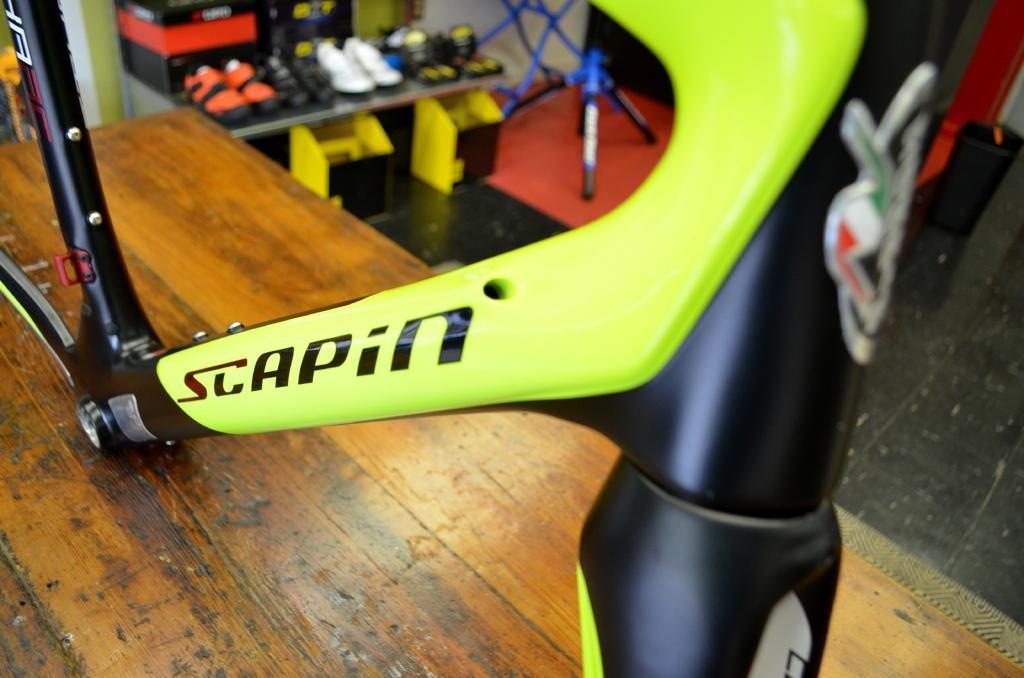What is the main object on the wooden surface in the image? There is a bicycle part on a wooden surface in the image. What can be seen in the racks in the image? There are shoes in racks in the image. What other objects are present in the image? There are some other objects in the image. How many dogs are lying on the quilt in the image? There are no dogs or quilts present in the image. 